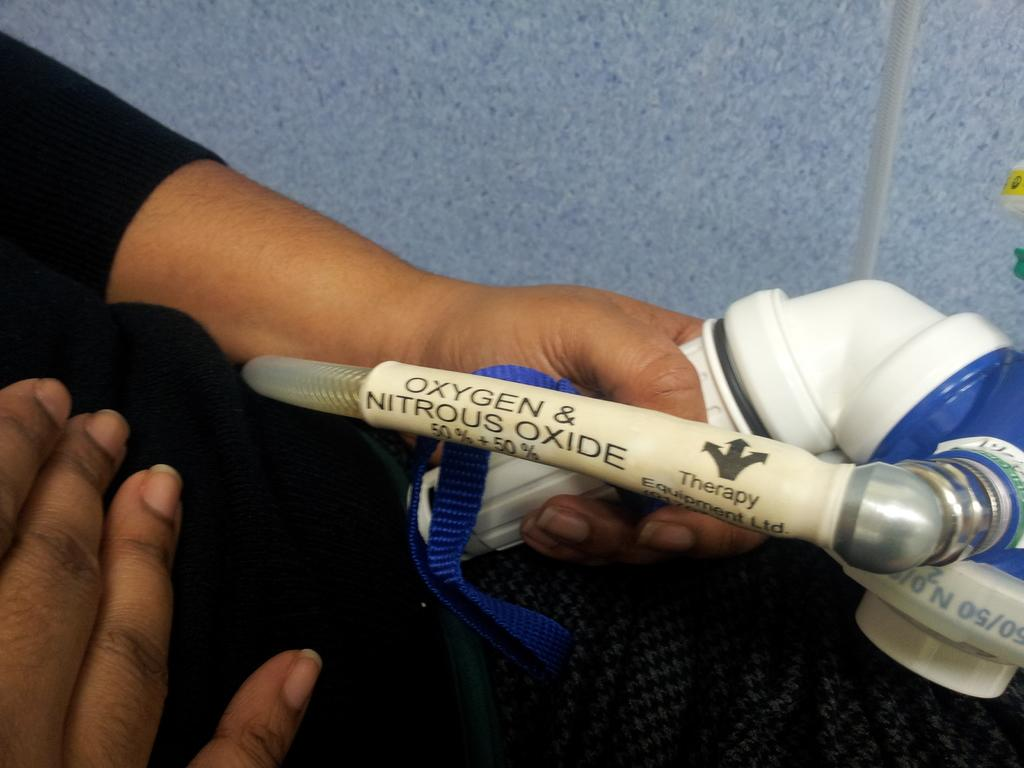Who is the main subject in the image? There is a lady in the image. Where is the lady located in the image? The lady is on the left side of the image. What is the lady holding in her hand? The lady is holding an oxygen pipe in her hand. What type of bun is the lady wearing on her head in the image? There is no bun visible on the lady's head in the image. 